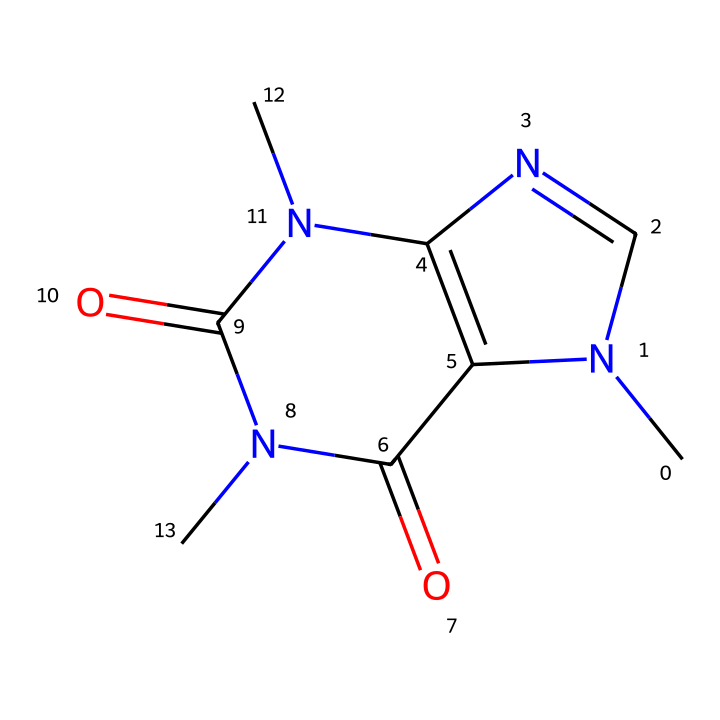What is the molecular formula of caffeine? To determine the molecular formula, one counts the number of each type of atom in the SMILES representation. The SMILES indicates there are 8 carbon (C) atoms, 10 hydrogen (H) atoms, 4 nitrogen (N) atoms, and 4 oxygen (O) atoms. Thus, the molecular formula is C8H10N4O2.
Answer: C8H10N4O2 How many rings are present in the caffeine structure? The structure shows two interconnected rings (the fused structure in the SMILES). Counting the rings directly from the SMILES leads to the conclusion that there are two rings in total.
Answer: 2 What type of compound is caffeine classified as? Caffeine is classified as an alkaloid. Alkaloids are nitrogen-containing compounds derived from plants, and caffeine contains multiple nitrogen atoms in its structure, indicating its alkaloid classification.
Answer: alkaloid How many nitrogen atoms are in caffeine? By examining the SMILES representation, we can count the nitrogen atoms represented by the "N" within the structure. There are four "N" atoms present in the caffeine chemical structure.
Answer: 4 What type of interaction does caffeine primarily have with the central nervous system? Caffeine primarily acts as a stimulant by blocking adenosine receptors in the brain, which is facilitated through its nitrogen-containing structure that allows for this interaction.
Answer: stimulant Which functional groups are present in caffeine? The structure of caffeine includes amine groups (due to the presence of nitrogen) and carbonyl groups (shown by C=O). These functional groups influence its reactivity and biological activity.
Answer: amine and carbonyl 